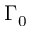<formula> <loc_0><loc_0><loc_500><loc_500>\Gamma _ { 0 }</formula> 